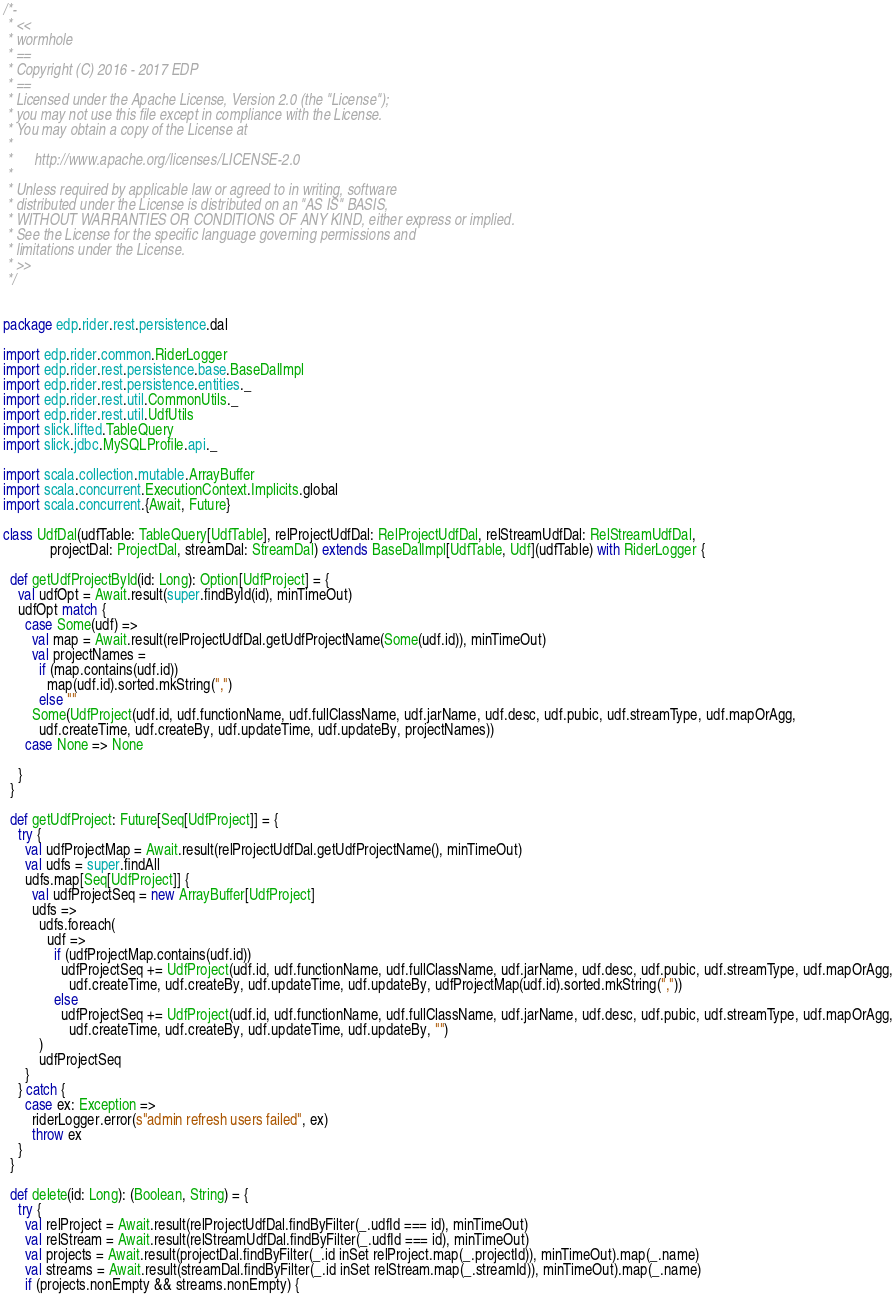Convert code to text. <code><loc_0><loc_0><loc_500><loc_500><_Scala_>/*-
 * <<
 * wormhole
 * ==
 * Copyright (C) 2016 - 2017 EDP
 * ==
 * Licensed under the Apache License, Version 2.0 (the "License");
 * you may not use this file except in compliance with the License.
 * You may obtain a copy of the License at
 *
 *      http://www.apache.org/licenses/LICENSE-2.0
 *
 * Unless required by applicable law or agreed to in writing, software
 * distributed under the License is distributed on an "AS IS" BASIS,
 * WITHOUT WARRANTIES OR CONDITIONS OF ANY KIND, either express or implied.
 * See the License for the specific language governing permissions and
 * limitations under the License.
 * >>
 */


package edp.rider.rest.persistence.dal

import edp.rider.common.RiderLogger
import edp.rider.rest.persistence.base.BaseDalImpl
import edp.rider.rest.persistence.entities._
import edp.rider.rest.util.CommonUtils._
import edp.rider.rest.util.UdfUtils
import slick.lifted.TableQuery
import slick.jdbc.MySQLProfile.api._

import scala.collection.mutable.ArrayBuffer
import scala.concurrent.ExecutionContext.Implicits.global
import scala.concurrent.{Await, Future}

class UdfDal(udfTable: TableQuery[UdfTable], relProjectUdfDal: RelProjectUdfDal, relStreamUdfDal: RelStreamUdfDal,
             projectDal: ProjectDal, streamDal: StreamDal) extends BaseDalImpl[UdfTable, Udf](udfTable) with RiderLogger {

  def getUdfProjectById(id: Long): Option[UdfProject] = {
    val udfOpt = Await.result(super.findById(id), minTimeOut)
    udfOpt match {
      case Some(udf) =>
        val map = Await.result(relProjectUdfDal.getUdfProjectName(Some(udf.id)), minTimeOut)
        val projectNames =
          if (map.contains(udf.id))
            map(udf.id).sorted.mkString(",")
          else ""
        Some(UdfProject(udf.id, udf.functionName, udf.fullClassName, udf.jarName, udf.desc, udf.pubic, udf.streamType, udf.mapOrAgg,
          udf.createTime, udf.createBy, udf.updateTime, udf.updateBy, projectNames))
      case None => None

    }
  }

  def getUdfProject: Future[Seq[UdfProject]] = {
    try {
      val udfProjectMap = Await.result(relProjectUdfDal.getUdfProjectName(), minTimeOut)
      val udfs = super.findAll
      udfs.map[Seq[UdfProject]] {
        val udfProjectSeq = new ArrayBuffer[UdfProject]
        udfs =>
          udfs.foreach(
            udf =>
              if (udfProjectMap.contains(udf.id))
                udfProjectSeq += UdfProject(udf.id, udf.functionName, udf.fullClassName, udf.jarName, udf.desc, udf.pubic, udf.streamType, udf.mapOrAgg,
                  udf.createTime, udf.createBy, udf.updateTime, udf.updateBy, udfProjectMap(udf.id).sorted.mkString(","))
              else
                udfProjectSeq += UdfProject(udf.id, udf.functionName, udf.fullClassName, udf.jarName, udf.desc, udf.pubic, udf.streamType, udf.mapOrAgg,
                  udf.createTime, udf.createBy, udf.updateTime, udf.updateBy, "")
          )
          udfProjectSeq
      }
    } catch {
      case ex: Exception =>
        riderLogger.error(s"admin refresh users failed", ex)
        throw ex
    }
  }

  def delete(id: Long): (Boolean, String) = {
    try {
      val relProject = Await.result(relProjectUdfDal.findByFilter(_.udfId === id), minTimeOut)
      val relStream = Await.result(relStreamUdfDal.findByFilter(_.udfId === id), minTimeOut)
      val projects = Await.result(projectDal.findByFilter(_.id inSet relProject.map(_.projectId)), minTimeOut).map(_.name)
      val streams = Await.result(streamDal.findByFilter(_.id inSet relStream.map(_.streamId)), minTimeOut).map(_.name)
      if (projects.nonEmpty && streams.nonEmpty) {</code> 